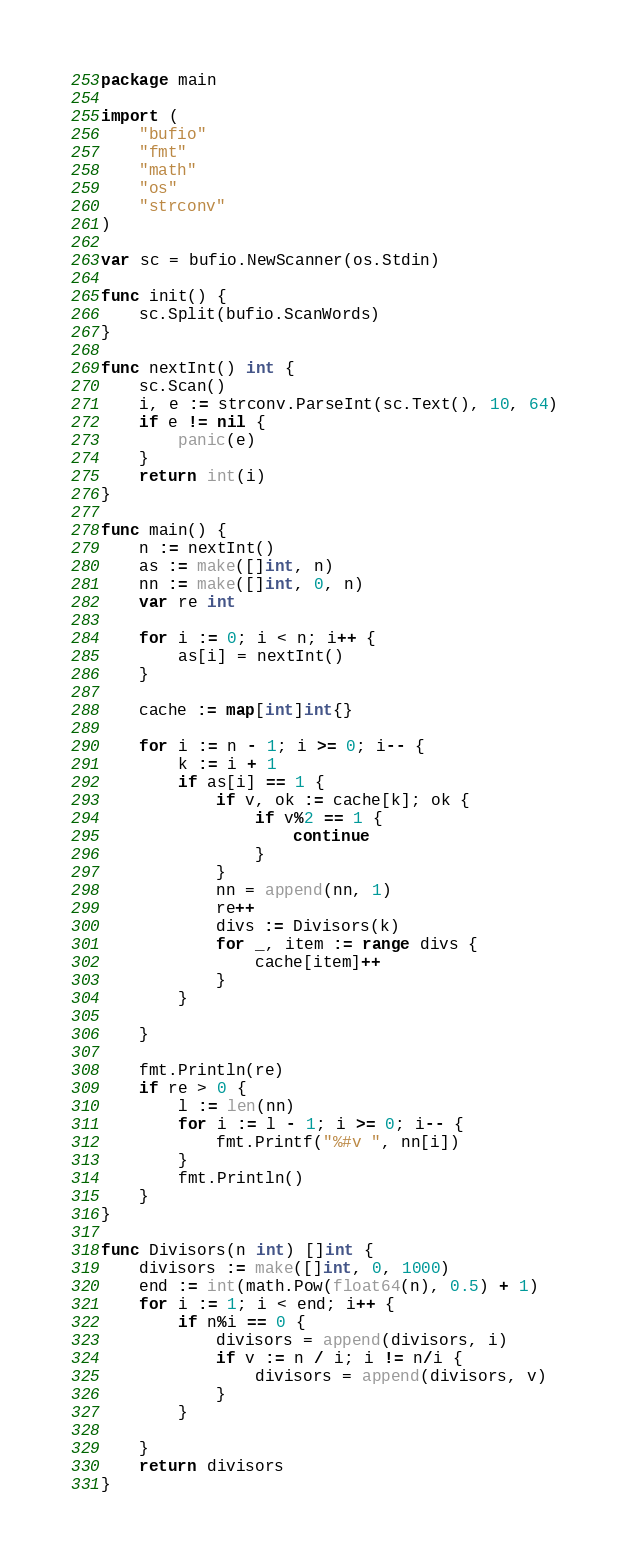Convert code to text. <code><loc_0><loc_0><loc_500><loc_500><_Go_>package main

import (
	"bufio"
	"fmt"
	"math"
	"os"
	"strconv"
)

var sc = bufio.NewScanner(os.Stdin)

func init() {
	sc.Split(bufio.ScanWords)
}

func nextInt() int {
	sc.Scan()
	i, e := strconv.ParseInt(sc.Text(), 10, 64)
	if e != nil {
		panic(e)
	}
	return int(i)
}

func main() {
	n := nextInt()
	as := make([]int, n)
	nn := make([]int, 0, n)
	var re int

	for i := 0; i < n; i++ {
		as[i] = nextInt()
	}

	cache := map[int]int{}

	for i := n - 1; i >= 0; i-- {
		k := i + 1
		if as[i] == 1 {
			if v, ok := cache[k]; ok {
				if v%2 == 1 {
					continue
				}
			}
			nn = append(nn, 1)
			re++
			divs := Divisors(k)
			for _, item := range divs {
				cache[item]++
			}
		}

	}

	fmt.Println(re)
	if re > 0 {
		l := len(nn)
		for i := l - 1; i >= 0; i-- {
			fmt.Printf("%#v ", nn[i])
		}
		fmt.Println()
	}
}

func Divisors(n int) []int {
	divisors := make([]int, 0, 1000)
	end := int(math.Pow(float64(n), 0.5) + 1)
	for i := 1; i < end; i++ {
		if n%i == 0 {
			divisors = append(divisors, i)
			if v := n / i; i != n/i {
				divisors = append(divisors, v)
			}
		}

	}
	return divisors
}
</code> 